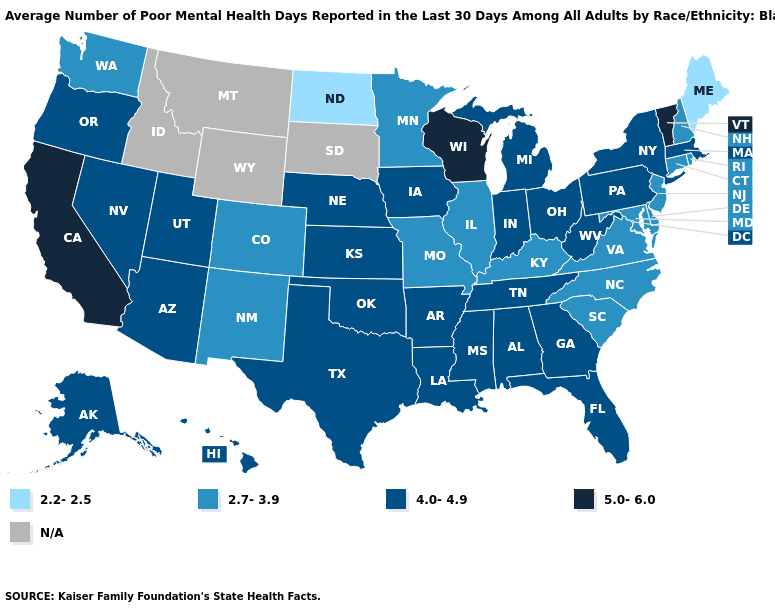Name the states that have a value in the range 2.7-3.9?
Quick response, please. Colorado, Connecticut, Delaware, Illinois, Kentucky, Maryland, Minnesota, Missouri, New Hampshire, New Jersey, New Mexico, North Carolina, Rhode Island, South Carolina, Virginia, Washington. Among the states that border Alabama , which have the highest value?
Write a very short answer. Florida, Georgia, Mississippi, Tennessee. What is the highest value in the Northeast ?
Concise answer only. 5.0-6.0. What is the value of Texas?
Keep it brief. 4.0-4.9. What is the value of Montana?
Give a very brief answer. N/A. What is the value of New Jersey?
Be succinct. 2.7-3.9. Does the first symbol in the legend represent the smallest category?
Keep it brief. Yes. What is the lowest value in states that border New Mexico?
Quick response, please. 2.7-3.9. What is the highest value in the West ?
Quick response, please. 5.0-6.0. What is the lowest value in states that border Tennessee?
Write a very short answer. 2.7-3.9. Among the states that border Minnesota , does North Dakota have the highest value?
Quick response, please. No. Name the states that have a value in the range 2.7-3.9?
Answer briefly. Colorado, Connecticut, Delaware, Illinois, Kentucky, Maryland, Minnesota, Missouri, New Hampshire, New Jersey, New Mexico, North Carolina, Rhode Island, South Carolina, Virginia, Washington. What is the value of Vermont?
Give a very brief answer. 5.0-6.0. 